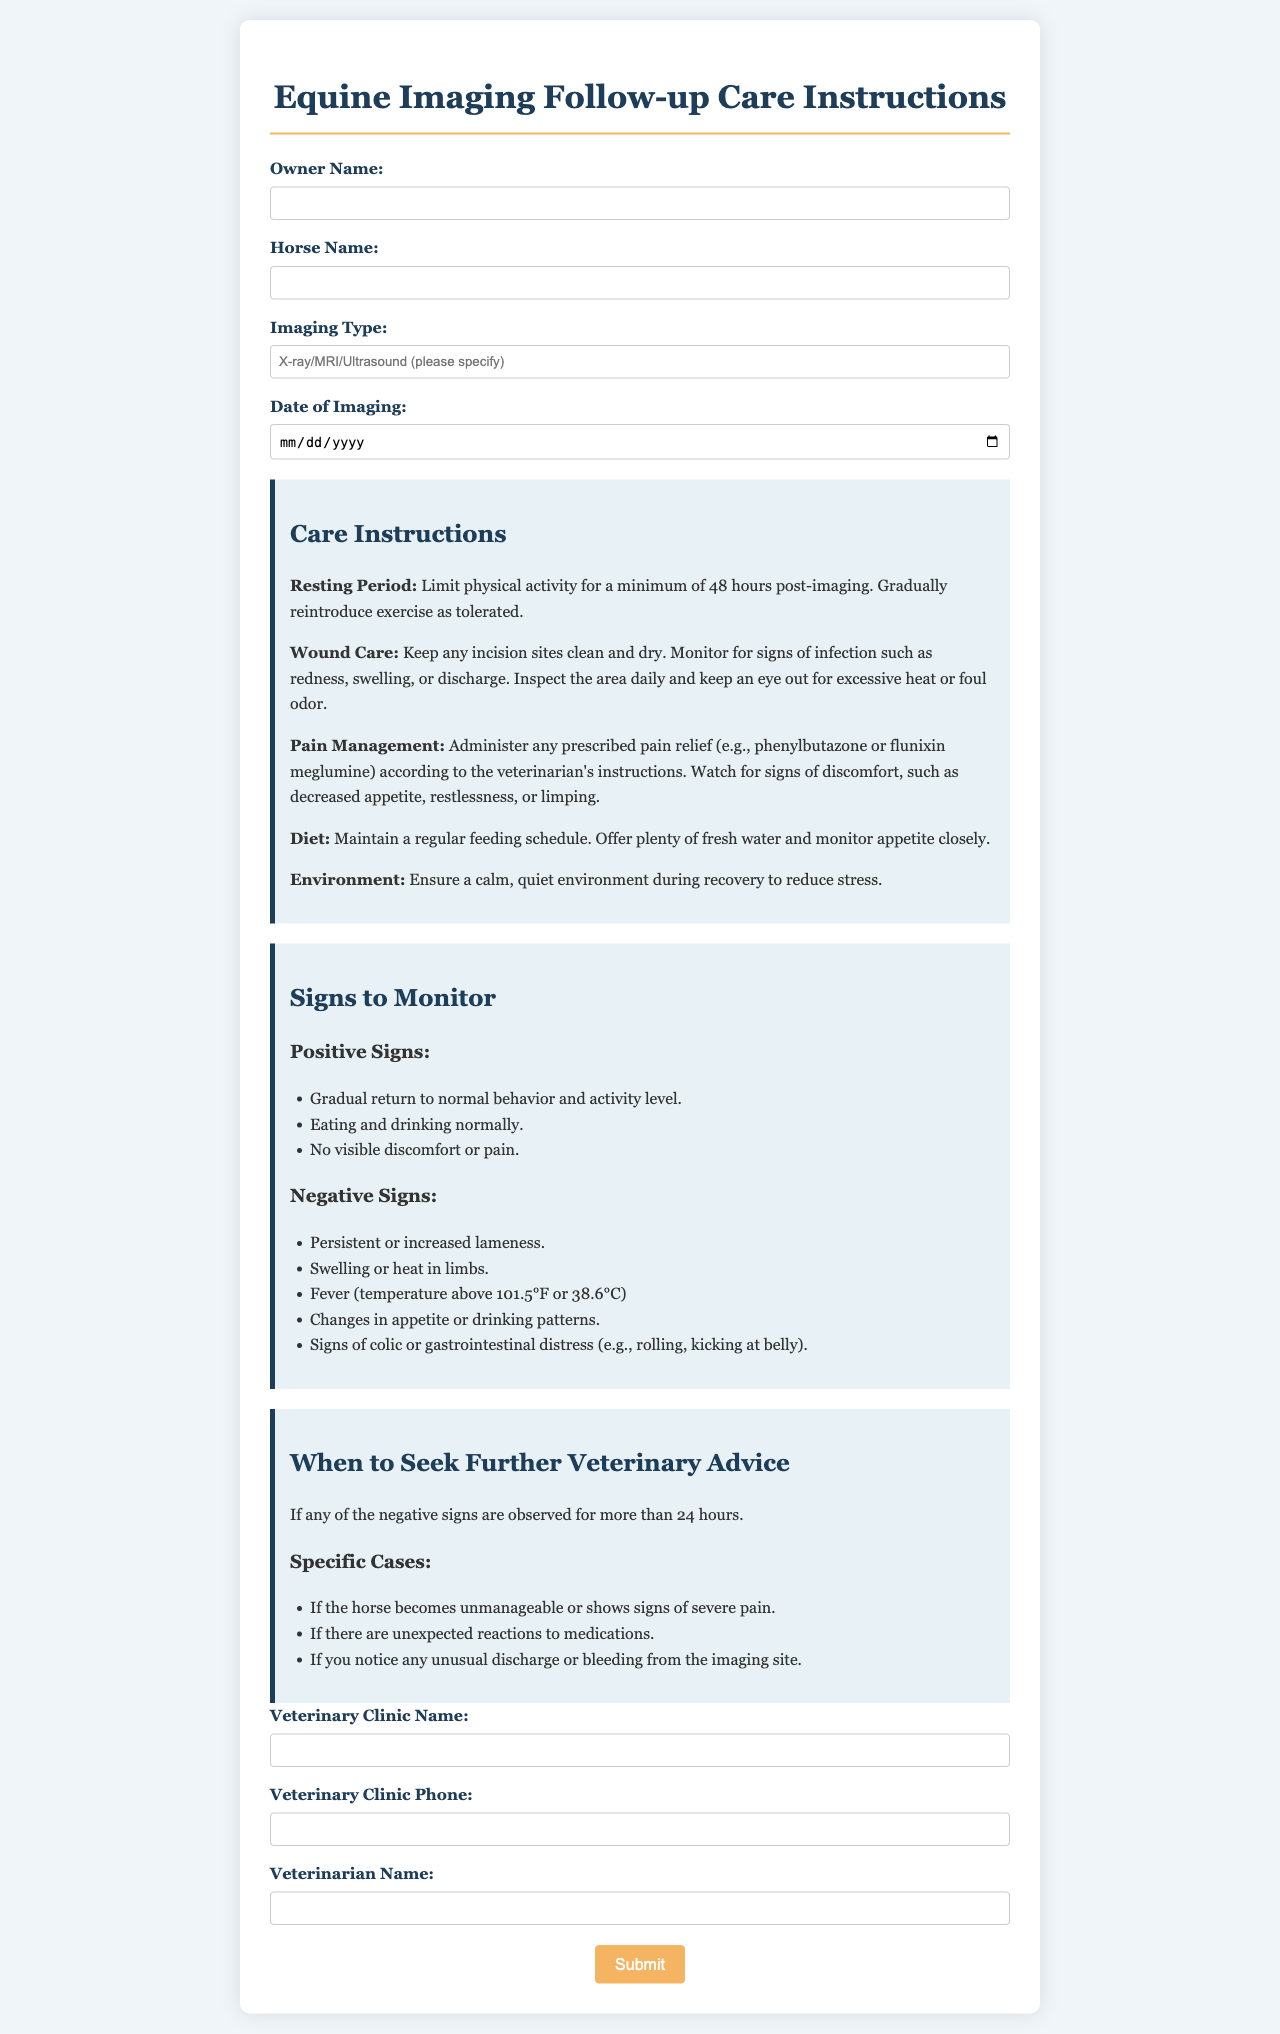What is the title of the document? The title of the document is displayed at the top of the rendered form as the main heading.
Answer: Equine Imaging Follow-up Care Instructions What is the required resting period post-imaging? The document specifies how long the horse should be limited in physical activity after imaging in the care instructions.
Answer: 48 hours What are the positive signs to monitor after the procedure? The document lists positive signs in the section about monitoring signs, which indicate recovery.
Answer: Gradual return to normal behavior and activity level, eating and drinking normally, no visible discomfort or pain When should further veterinary advice be sought? The document outlines conditions under which horse owners should contact their veterinarian for further advice, based on observed signs.
Answer: If any negative signs are observed for more than 24 hours What should be done if unusual discharge occurs? The document mentions specific actions that should be taken regarding the imaging site and any unexpected reactions.
Answer: Seek further veterinary advice What is an example of a negative sign to monitor? The document provides examples of negative signs that indicate potential complications post-imaging.
Answer: Persistent or increased lameness What type of care is advised regarding incision sites? The document provides care instructions related to managing the aftermath of the imaging procedure, specifically for incision sites.
Answer: Keep any incision sites clean and dry Who should be listed in the veterinary clinic name field? The field for veterinary clinic name requests specific information based on the document's structure.
Answer: The name of the veterinary clinic What color is used for the headings in the document? The visual style of the document is determined by the CSS styling, which sets the color of headings.
Answer: #1e3d59 